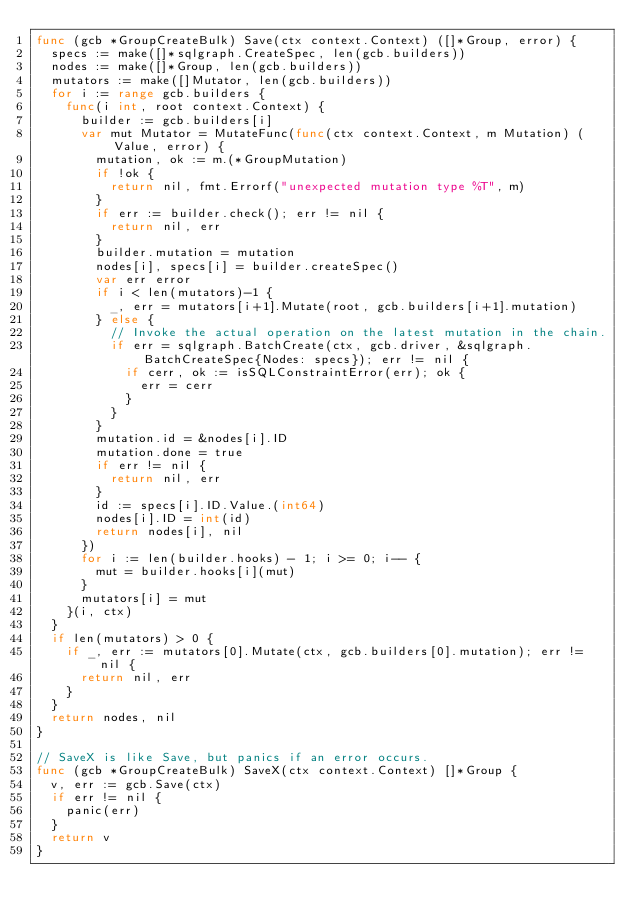<code> <loc_0><loc_0><loc_500><loc_500><_Go_>func (gcb *GroupCreateBulk) Save(ctx context.Context) ([]*Group, error) {
	specs := make([]*sqlgraph.CreateSpec, len(gcb.builders))
	nodes := make([]*Group, len(gcb.builders))
	mutators := make([]Mutator, len(gcb.builders))
	for i := range gcb.builders {
		func(i int, root context.Context) {
			builder := gcb.builders[i]
			var mut Mutator = MutateFunc(func(ctx context.Context, m Mutation) (Value, error) {
				mutation, ok := m.(*GroupMutation)
				if !ok {
					return nil, fmt.Errorf("unexpected mutation type %T", m)
				}
				if err := builder.check(); err != nil {
					return nil, err
				}
				builder.mutation = mutation
				nodes[i], specs[i] = builder.createSpec()
				var err error
				if i < len(mutators)-1 {
					_, err = mutators[i+1].Mutate(root, gcb.builders[i+1].mutation)
				} else {
					// Invoke the actual operation on the latest mutation in the chain.
					if err = sqlgraph.BatchCreate(ctx, gcb.driver, &sqlgraph.BatchCreateSpec{Nodes: specs}); err != nil {
						if cerr, ok := isSQLConstraintError(err); ok {
							err = cerr
						}
					}
				}
				mutation.id = &nodes[i].ID
				mutation.done = true
				if err != nil {
					return nil, err
				}
				id := specs[i].ID.Value.(int64)
				nodes[i].ID = int(id)
				return nodes[i], nil
			})
			for i := len(builder.hooks) - 1; i >= 0; i-- {
				mut = builder.hooks[i](mut)
			}
			mutators[i] = mut
		}(i, ctx)
	}
	if len(mutators) > 0 {
		if _, err := mutators[0].Mutate(ctx, gcb.builders[0].mutation); err != nil {
			return nil, err
		}
	}
	return nodes, nil
}

// SaveX is like Save, but panics if an error occurs.
func (gcb *GroupCreateBulk) SaveX(ctx context.Context) []*Group {
	v, err := gcb.Save(ctx)
	if err != nil {
		panic(err)
	}
	return v
}
</code> 